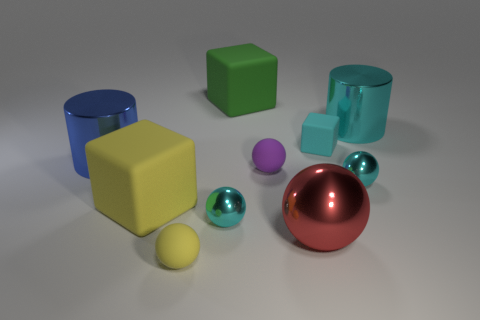Is the color of the shiny cylinder to the right of the tiny yellow thing the same as the tiny rubber cube?
Your response must be concise. Yes. Are there the same number of metal objects that are left of the large cyan metallic cylinder and cyan things?
Provide a short and direct response. Yes. How many objects are on the left side of the small yellow rubber object and in front of the blue object?
Provide a succinct answer. 1. There is a large matte object that is behind the big blue object; is it the same shape as the large yellow thing?
Offer a terse response. Yes. There is a cyan cylinder that is the same size as the blue metal object; what material is it?
Your answer should be very brief. Metal. Is the number of blue shiny objects to the right of the big yellow cube the same as the number of large cylinders right of the tiny yellow ball?
Offer a terse response. No. There is a shiny cylinder on the right side of the rubber block to the right of the purple sphere; what number of big things are in front of it?
Provide a succinct answer. 3. Is the color of the small rubber block the same as the metal ball that is right of the cyan matte thing?
Keep it short and to the point. Yes. The purple thing that is made of the same material as the green thing is what size?
Your answer should be very brief. Small. Are there more matte objects that are left of the big blue object than big purple rubber things?
Provide a succinct answer. No. 